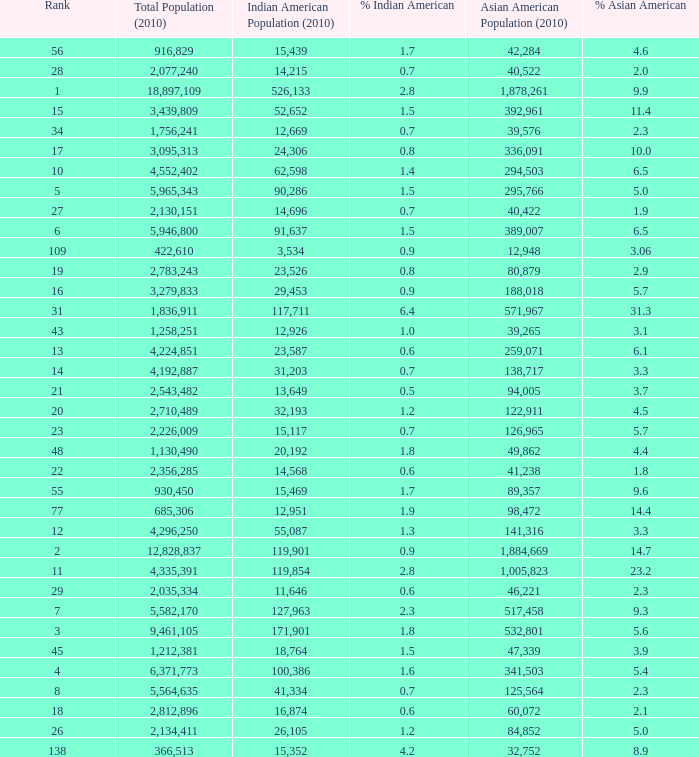What's the total population when there are 5.7% Asian American and fewer than 126,965 Asian American Population? None. 